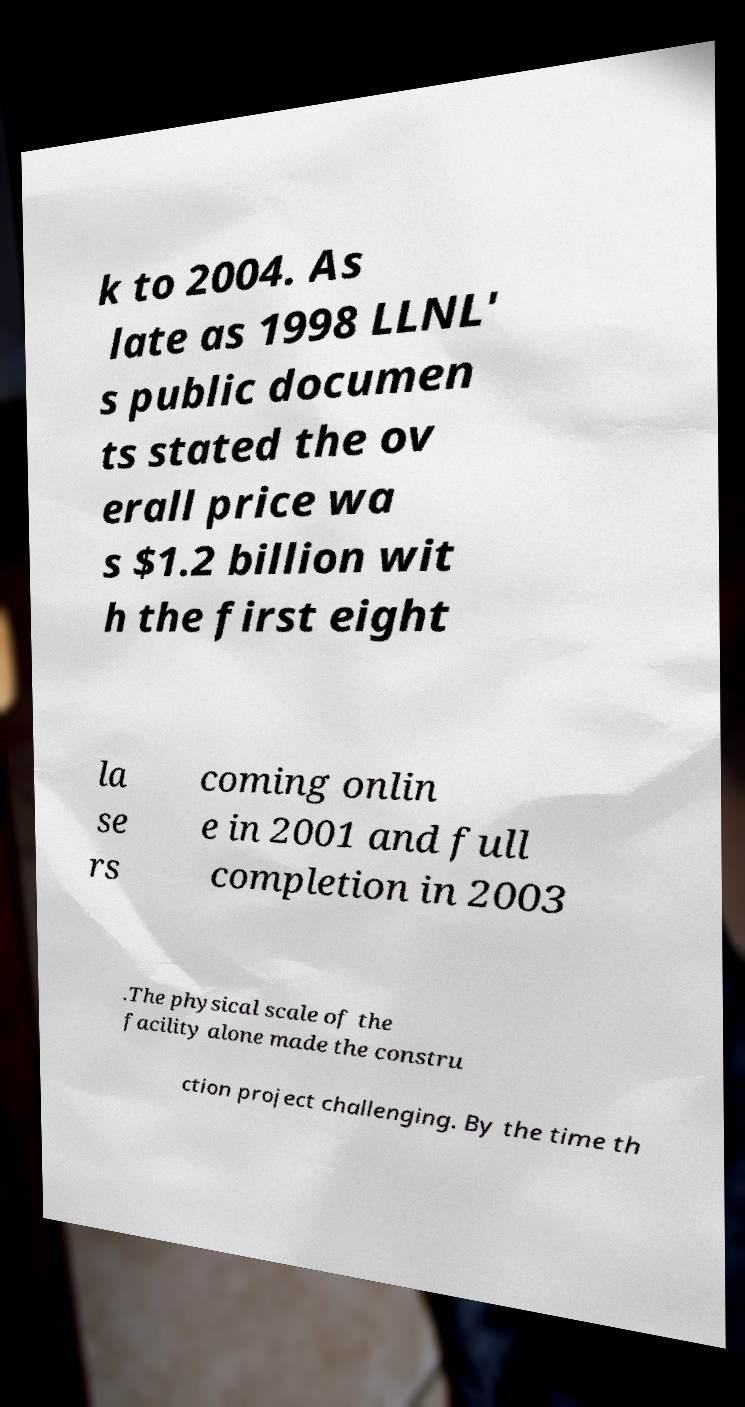Could you assist in decoding the text presented in this image and type it out clearly? k to 2004. As late as 1998 LLNL' s public documen ts stated the ov erall price wa s $1.2 billion wit h the first eight la se rs coming onlin e in 2001 and full completion in 2003 .The physical scale of the facility alone made the constru ction project challenging. By the time th 